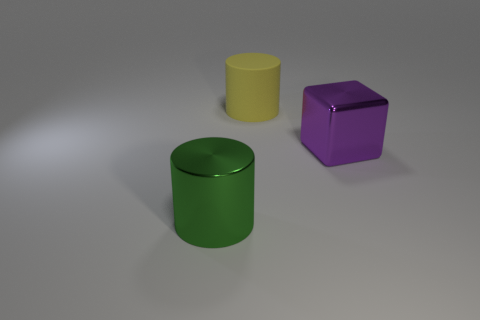Is the number of rubber objects behind the green cylinder greater than the number of yellow metallic things?
Offer a very short reply. Yes. What number of other things are there of the same shape as the big purple thing?
Your answer should be very brief. 0. There is a large thing that is both in front of the large yellow matte object and behind the big metal cylinder; what material is it?
Ensure brevity in your answer.  Metal. How many objects are either large gray metallic spheres or shiny objects?
Your answer should be compact. 2. Are there more big purple cubes than big cylinders?
Your response must be concise. No. There is a metallic object that is to the right of the big metallic object left of the large purple block; how big is it?
Provide a succinct answer. Large. The other big object that is the same shape as the large yellow matte thing is what color?
Provide a short and direct response. Green. How many blocks are tiny cyan matte things or yellow rubber things?
Ensure brevity in your answer.  0. What number of big green metal cylinders are there?
Keep it short and to the point. 1. There is a matte object; is it the same shape as the large metal object behind the big green object?
Your response must be concise. No. 